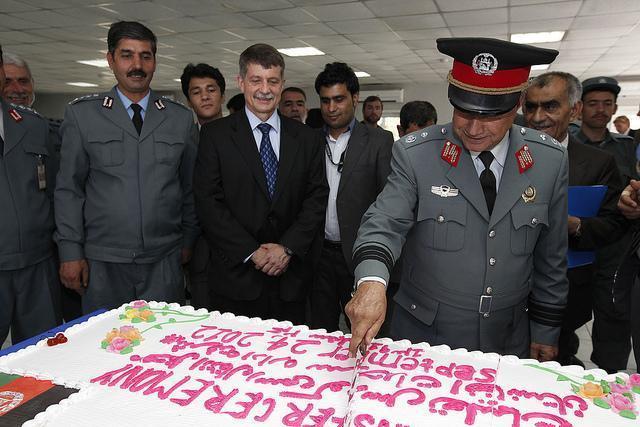How many cakes are there?
Give a very brief answer. 1. How many people are visible?
Give a very brief answer. 8. How many people running with a kite on the sand?
Give a very brief answer. 0. 